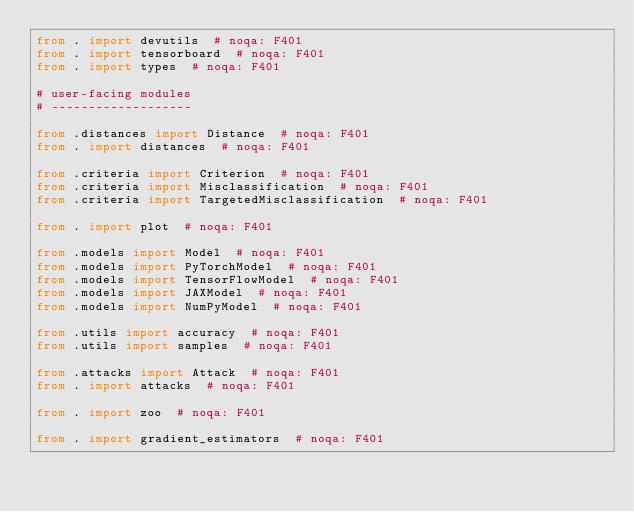Convert code to text. <code><loc_0><loc_0><loc_500><loc_500><_Python_>from . import devutils  # noqa: F401
from . import tensorboard  # noqa: F401
from . import types  # noqa: F401

# user-facing modules
# -------------------

from .distances import Distance  # noqa: F401
from . import distances  # noqa: F401

from .criteria import Criterion  # noqa: F401
from .criteria import Misclassification  # noqa: F401
from .criteria import TargetedMisclassification  # noqa: F401

from . import plot  # noqa: F401

from .models import Model  # noqa: F401
from .models import PyTorchModel  # noqa: F401
from .models import TensorFlowModel  # noqa: F401
from .models import JAXModel  # noqa: F401
from .models import NumPyModel  # noqa: F401

from .utils import accuracy  # noqa: F401
from .utils import samples  # noqa: F401

from .attacks import Attack  # noqa: F401
from . import attacks  # noqa: F401

from . import zoo  # noqa: F401

from . import gradient_estimators  # noqa: F401
</code> 